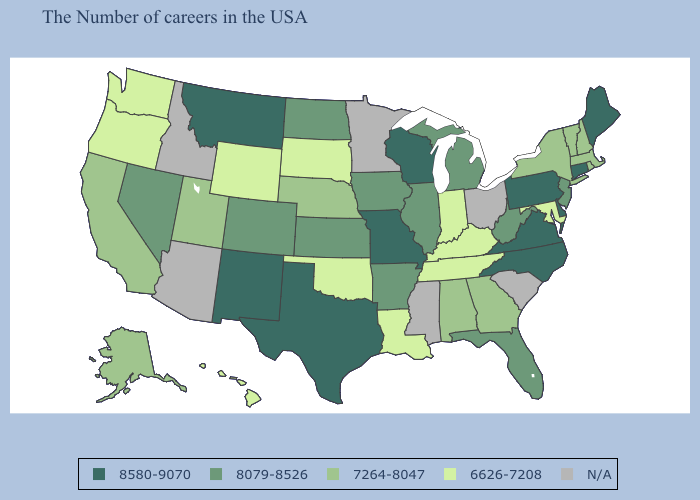Among the states that border Louisiana , does Arkansas have the highest value?
Give a very brief answer. No. Does Missouri have the highest value in the MidWest?
Give a very brief answer. Yes. What is the highest value in states that border Alabama?
Short answer required. 8079-8526. Among the states that border Tennessee , does Georgia have the lowest value?
Write a very short answer. No. Name the states that have a value in the range 8079-8526?
Keep it brief. New Jersey, West Virginia, Florida, Michigan, Illinois, Arkansas, Iowa, Kansas, North Dakota, Colorado, Nevada. What is the value of Montana?
Short answer required. 8580-9070. Name the states that have a value in the range 8079-8526?
Be succinct. New Jersey, West Virginia, Florida, Michigan, Illinois, Arkansas, Iowa, Kansas, North Dakota, Colorado, Nevada. What is the lowest value in states that border Oregon?
Quick response, please. 6626-7208. Which states have the lowest value in the USA?
Keep it brief. Maryland, Kentucky, Indiana, Tennessee, Louisiana, Oklahoma, South Dakota, Wyoming, Washington, Oregon, Hawaii. Which states have the lowest value in the USA?
Give a very brief answer. Maryland, Kentucky, Indiana, Tennessee, Louisiana, Oklahoma, South Dakota, Wyoming, Washington, Oregon, Hawaii. What is the value of Connecticut?
Keep it brief. 8580-9070. Does New York have the lowest value in the Northeast?
Answer briefly. Yes. What is the lowest value in the South?
Write a very short answer. 6626-7208. 